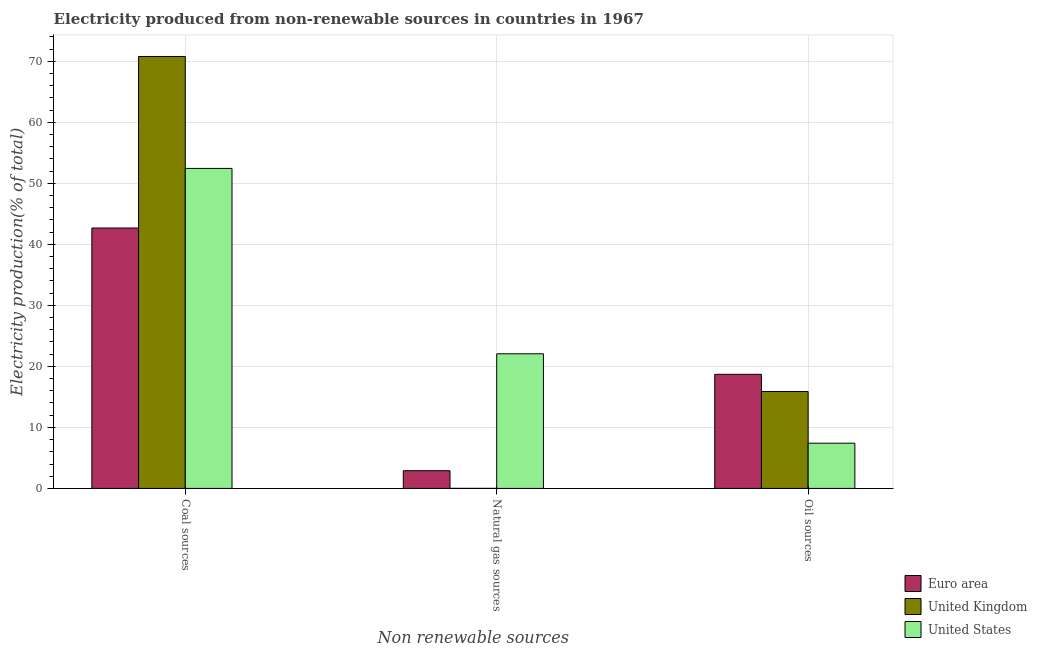How many different coloured bars are there?
Provide a succinct answer. 3. How many groups of bars are there?
Your answer should be compact. 3. Are the number of bars per tick equal to the number of legend labels?
Offer a very short reply. Yes. How many bars are there on the 3rd tick from the left?
Give a very brief answer. 3. What is the label of the 1st group of bars from the left?
Provide a short and direct response. Coal sources. What is the percentage of electricity produced by oil sources in Euro area?
Make the answer very short. 18.7. Across all countries, what is the maximum percentage of electricity produced by coal?
Provide a short and direct response. 70.79. Across all countries, what is the minimum percentage of electricity produced by oil sources?
Provide a succinct answer. 7.41. What is the total percentage of electricity produced by coal in the graph?
Ensure brevity in your answer.  165.91. What is the difference between the percentage of electricity produced by natural gas in United Kingdom and that in Euro area?
Keep it short and to the point. -2.89. What is the difference between the percentage of electricity produced by oil sources in United States and the percentage of electricity produced by coal in United Kingdom?
Provide a succinct answer. -63.38. What is the average percentage of electricity produced by natural gas per country?
Provide a short and direct response. 8.32. What is the difference between the percentage of electricity produced by oil sources and percentage of electricity produced by coal in United Kingdom?
Your answer should be very brief. -54.91. In how many countries, is the percentage of electricity produced by oil sources greater than 58 %?
Offer a very short reply. 0. What is the ratio of the percentage of electricity produced by natural gas in United States to that in United Kingdom?
Ensure brevity in your answer.  3052.99. Is the percentage of electricity produced by coal in United States less than that in United Kingdom?
Make the answer very short. Yes. Is the difference between the percentage of electricity produced by coal in United Kingdom and Euro area greater than the difference between the percentage of electricity produced by oil sources in United Kingdom and Euro area?
Your answer should be compact. Yes. What is the difference between the highest and the second highest percentage of electricity produced by oil sources?
Provide a succinct answer. 2.82. What is the difference between the highest and the lowest percentage of electricity produced by natural gas?
Provide a short and direct response. 22.06. What does the 2nd bar from the left in Natural gas sources represents?
Give a very brief answer. United Kingdom. Are all the bars in the graph horizontal?
Make the answer very short. No. Are the values on the major ticks of Y-axis written in scientific E-notation?
Ensure brevity in your answer.  No. Does the graph contain grids?
Provide a short and direct response. Yes. How are the legend labels stacked?
Keep it short and to the point. Vertical. What is the title of the graph?
Your response must be concise. Electricity produced from non-renewable sources in countries in 1967. What is the label or title of the X-axis?
Offer a very short reply. Non renewable sources. What is the Electricity production(% of total) of Euro area in Coal sources?
Provide a succinct answer. 42.68. What is the Electricity production(% of total) of United Kingdom in Coal sources?
Keep it short and to the point. 70.79. What is the Electricity production(% of total) of United States in Coal sources?
Your response must be concise. 52.45. What is the Electricity production(% of total) of Euro area in Natural gas sources?
Provide a succinct answer. 2.9. What is the Electricity production(% of total) of United Kingdom in Natural gas sources?
Ensure brevity in your answer.  0.01. What is the Electricity production(% of total) in United States in Natural gas sources?
Your answer should be compact. 22.06. What is the Electricity production(% of total) in Euro area in Oil sources?
Offer a terse response. 18.7. What is the Electricity production(% of total) of United Kingdom in Oil sources?
Make the answer very short. 15.88. What is the Electricity production(% of total) in United States in Oil sources?
Provide a short and direct response. 7.41. Across all Non renewable sources, what is the maximum Electricity production(% of total) of Euro area?
Provide a succinct answer. 42.68. Across all Non renewable sources, what is the maximum Electricity production(% of total) of United Kingdom?
Make the answer very short. 70.79. Across all Non renewable sources, what is the maximum Electricity production(% of total) in United States?
Offer a terse response. 52.45. Across all Non renewable sources, what is the minimum Electricity production(% of total) of Euro area?
Your answer should be very brief. 2.9. Across all Non renewable sources, what is the minimum Electricity production(% of total) in United Kingdom?
Provide a short and direct response. 0.01. Across all Non renewable sources, what is the minimum Electricity production(% of total) of United States?
Your response must be concise. 7.41. What is the total Electricity production(% of total) in Euro area in the graph?
Keep it short and to the point. 64.27. What is the total Electricity production(% of total) in United Kingdom in the graph?
Give a very brief answer. 86.67. What is the total Electricity production(% of total) in United States in the graph?
Ensure brevity in your answer.  81.92. What is the difference between the Electricity production(% of total) of Euro area in Coal sources and that in Natural gas sources?
Ensure brevity in your answer.  39.78. What is the difference between the Electricity production(% of total) of United Kingdom in Coal sources and that in Natural gas sources?
Provide a succinct answer. 70.78. What is the difference between the Electricity production(% of total) of United States in Coal sources and that in Natural gas sources?
Make the answer very short. 30.38. What is the difference between the Electricity production(% of total) in Euro area in Coal sources and that in Oil sources?
Ensure brevity in your answer.  23.98. What is the difference between the Electricity production(% of total) of United Kingdom in Coal sources and that in Oil sources?
Provide a succinct answer. 54.91. What is the difference between the Electricity production(% of total) in United States in Coal sources and that in Oil sources?
Provide a succinct answer. 45.03. What is the difference between the Electricity production(% of total) in Euro area in Natural gas sources and that in Oil sources?
Provide a succinct answer. -15.8. What is the difference between the Electricity production(% of total) of United Kingdom in Natural gas sources and that in Oil sources?
Provide a short and direct response. -15.87. What is the difference between the Electricity production(% of total) of United States in Natural gas sources and that in Oil sources?
Offer a very short reply. 14.65. What is the difference between the Electricity production(% of total) of Euro area in Coal sources and the Electricity production(% of total) of United Kingdom in Natural gas sources?
Make the answer very short. 42.67. What is the difference between the Electricity production(% of total) of Euro area in Coal sources and the Electricity production(% of total) of United States in Natural gas sources?
Provide a succinct answer. 20.61. What is the difference between the Electricity production(% of total) in United Kingdom in Coal sources and the Electricity production(% of total) in United States in Natural gas sources?
Your response must be concise. 48.73. What is the difference between the Electricity production(% of total) in Euro area in Coal sources and the Electricity production(% of total) in United Kingdom in Oil sources?
Provide a short and direct response. 26.8. What is the difference between the Electricity production(% of total) in Euro area in Coal sources and the Electricity production(% of total) in United States in Oil sources?
Your response must be concise. 35.27. What is the difference between the Electricity production(% of total) of United Kingdom in Coal sources and the Electricity production(% of total) of United States in Oil sources?
Ensure brevity in your answer.  63.38. What is the difference between the Electricity production(% of total) of Euro area in Natural gas sources and the Electricity production(% of total) of United Kingdom in Oil sources?
Offer a very short reply. -12.98. What is the difference between the Electricity production(% of total) in Euro area in Natural gas sources and the Electricity production(% of total) in United States in Oil sources?
Make the answer very short. -4.51. What is the difference between the Electricity production(% of total) in United Kingdom in Natural gas sources and the Electricity production(% of total) in United States in Oil sources?
Provide a short and direct response. -7.4. What is the average Electricity production(% of total) of Euro area per Non renewable sources?
Make the answer very short. 21.42. What is the average Electricity production(% of total) in United Kingdom per Non renewable sources?
Your answer should be very brief. 28.89. What is the average Electricity production(% of total) of United States per Non renewable sources?
Make the answer very short. 27.31. What is the difference between the Electricity production(% of total) of Euro area and Electricity production(% of total) of United Kingdom in Coal sources?
Provide a succinct answer. -28.11. What is the difference between the Electricity production(% of total) of Euro area and Electricity production(% of total) of United States in Coal sources?
Provide a succinct answer. -9.77. What is the difference between the Electricity production(% of total) in United Kingdom and Electricity production(% of total) in United States in Coal sources?
Your answer should be compact. 18.34. What is the difference between the Electricity production(% of total) of Euro area and Electricity production(% of total) of United Kingdom in Natural gas sources?
Provide a short and direct response. 2.89. What is the difference between the Electricity production(% of total) in Euro area and Electricity production(% of total) in United States in Natural gas sources?
Your answer should be very brief. -19.16. What is the difference between the Electricity production(% of total) in United Kingdom and Electricity production(% of total) in United States in Natural gas sources?
Offer a terse response. -22.06. What is the difference between the Electricity production(% of total) of Euro area and Electricity production(% of total) of United Kingdom in Oil sources?
Offer a terse response. 2.82. What is the difference between the Electricity production(% of total) in Euro area and Electricity production(% of total) in United States in Oil sources?
Provide a short and direct response. 11.29. What is the difference between the Electricity production(% of total) of United Kingdom and Electricity production(% of total) of United States in Oil sources?
Your answer should be compact. 8.47. What is the ratio of the Electricity production(% of total) of Euro area in Coal sources to that in Natural gas sources?
Offer a terse response. 14.71. What is the ratio of the Electricity production(% of total) of United Kingdom in Coal sources to that in Natural gas sources?
Provide a succinct answer. 9794.87. What is the ratio of the Electricity production(% of total) of United States in Coal sources to that in Natural gas sources?
Give a very brief answer. 2.38. What is the ratio of the Electricity production(% of total) in Euro area in Coal sources to that in Oil sources?
Make the answer very short. 2.28. What is the ratio of the Electricity production(% of total) of United Kingdom in Coal sources to that in Oil sources?
Provide a succinct answer. 4.46. What is the ratio of the Electricity production(% of total) in United States in Coal sources to that in Oil sources?
Your answer should be very brief. 7.08. What is the ratio of the Electricity production(% of total) of Euro area in Natural gas sources to that in Oil sources?
Your response must be concise. 0.16. What is the ratio of the Electricity production(% of total) in United Kingdom in Natural gas sources to that in Oil sources?
Offer a very short reply. 0. What is the ratio of the Electricity production(% of total) of United States in Natural gas sources to that in Oil sources?
Offer a very short reply. 2.98. What is the difference between the highest and the second highest Electricity production(% of total) in Euro area?
Keep it short and to the point. 23.98. What is the difference between the highest and the second highest Electricity production(% of total) of United Kingdom?
Keep it short and to the point. 54.91. What is the difference between the highest and the second highest Electricity production(% of total) in United States?
Offer a very short reply. 30.38. What is the difference between the highest and the lowest Electricity production(% of total) of Euro area?
Make the answer very short. 39.78. What is the difference between the highest and the lowest Electricity production(% of total) of United Kingdom?
Make the answer very short. 70.78. What is the difference between the highest and the lowest Electricity production(% of total) of United States?
Your response must be concise. 45.03. 